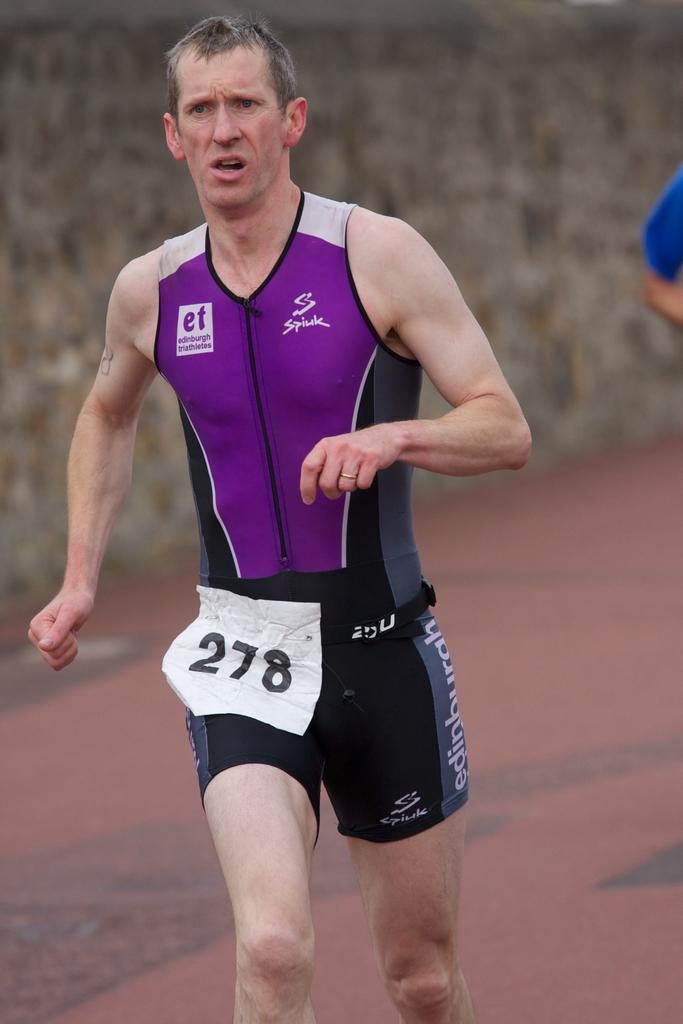<image>
Summarize the visual content of the image. The male runner is wearing the number 278 on his bib. 